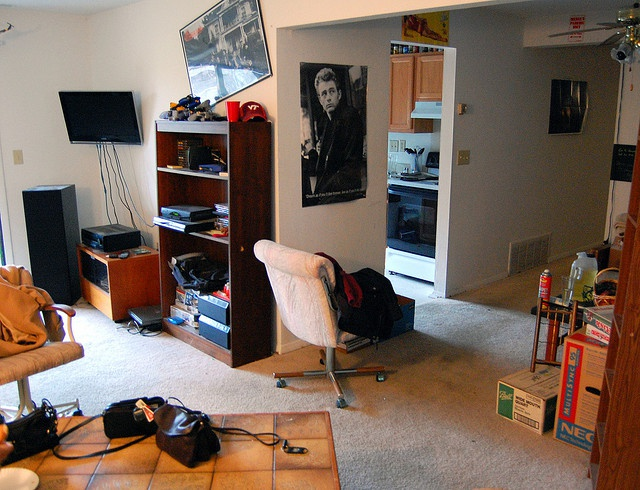Describe the objects in this image and their specific colors. I can see chair in darkgray, lightgray, tan, and black tones, chair in darkgray, brown, red, maroon, and salmon tones, people in darkgray, black, and gray tones, tv in darkgray, black, gray, and darkblue tones, and oven in darkgray, black, navy, blue, and gray tones in this image. 